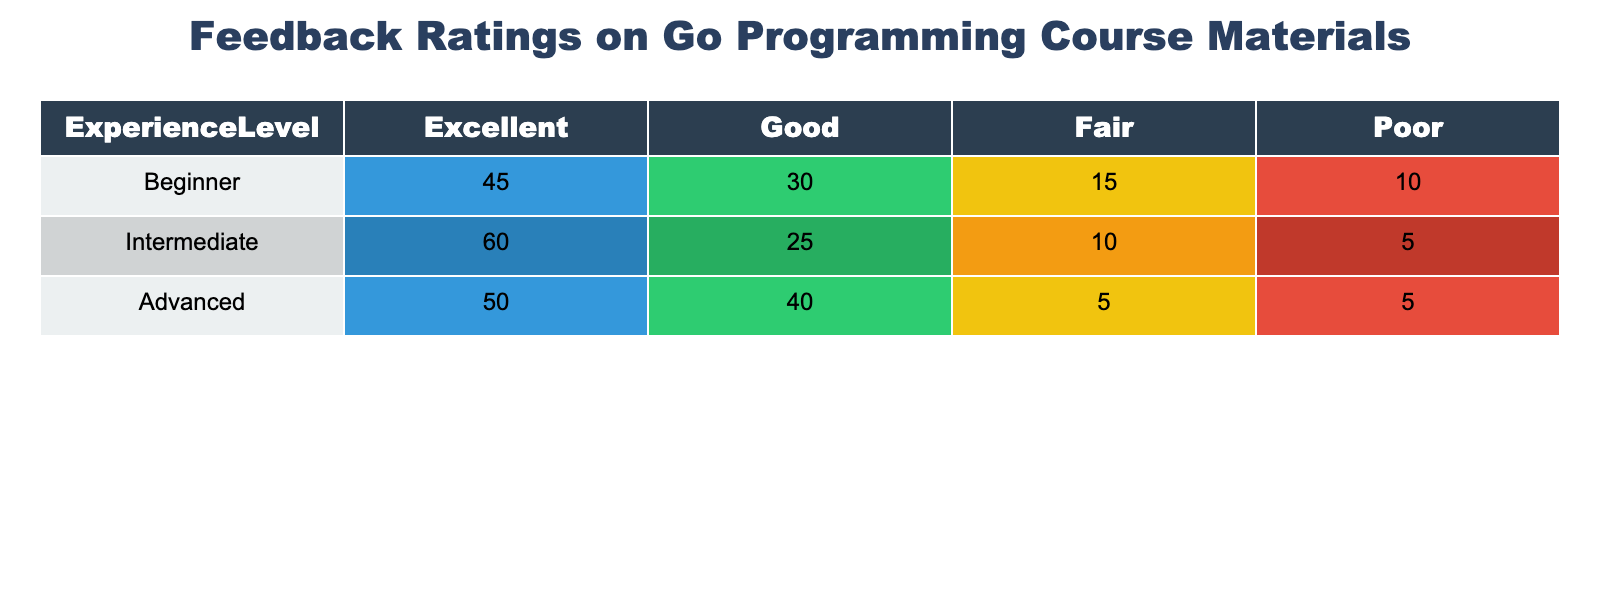What is the total number of feedback ratings from Beginners? To find the total number of feedback ratings from Beginners, we add the ratings across all categories: Excellent (45), Good (30), Fair (15), and Poor (10). So, the total is 45 + 30 + 15 + 10 = 100.
Answer: 100 What percentage of Intermediate participants rated the course materials as Excellent? The number of Intermediate participants rating Excellent is 60, and the total number of ratings from Intermediate is 60 + 25 + 10 + 5 = 100. To find the percentage, we use (60 / 100) * 100 = 60%.
Answer: 60% Is the number of Advanced participants who rated the materials as Fair greater than those who rated as Poor? The number of Advanced participants who rated as Fair is 5 and those who rated as Poor is also 5. Since these numbers are equal, the statement is false.
Answer: No What is the median rating for the Beginner experience level? The ratings for Beginner are Excellent (45), Good (30), Fair (15), and Poor (10). When arranged in increasing order, we have 10, 15, 30, 45. The median is the average of the two middle values (15 and 30), which is (15 + 30) / 2 = 22.5.
Answer: 22.5 How many more participants rated the materials as Excellent compared to those who rated it as Poor across all experience levels? For Excellent: Beginners (45) + Intermediate (60) + Advanced (50) = 155. For Poor: Beginners (10) + Intermediate (5) + Advanced (5) = 20. The difference is 155 - 20 = 135.
Answer: 135 What is the total number of ratings for Poor across all experience levels? To get the total Poor ratings, we add the Poor ratings from each experience level: Beginners (10), Intermediate (5), and Advanced (5). Therefore, the total is 10 + 5 + 5 = 20.
Answer: 20 Which experience level has the highest total ratings and what is that total? We calculate the total for each experience level: Beginner (100), Intermediate (100), and Advanced (100). All experience levels have the same total ratings, which is 100.
Answer: 100 Which experience level has the highest percentage of ratings as Good? The percentages for Good ratings are: Beginners (30/100 = 30%), Intermediate (25/100 = 25%), and Advanced (40/100 = 40%). Advanced has the highest percentage at 40%.
Answer: Advanced How does the total number of ratings compare between Beginners and Advanced? Both Beginner (100) and Advanced (100) have the same total ratings, so they are equal.
Answer: They are equal 